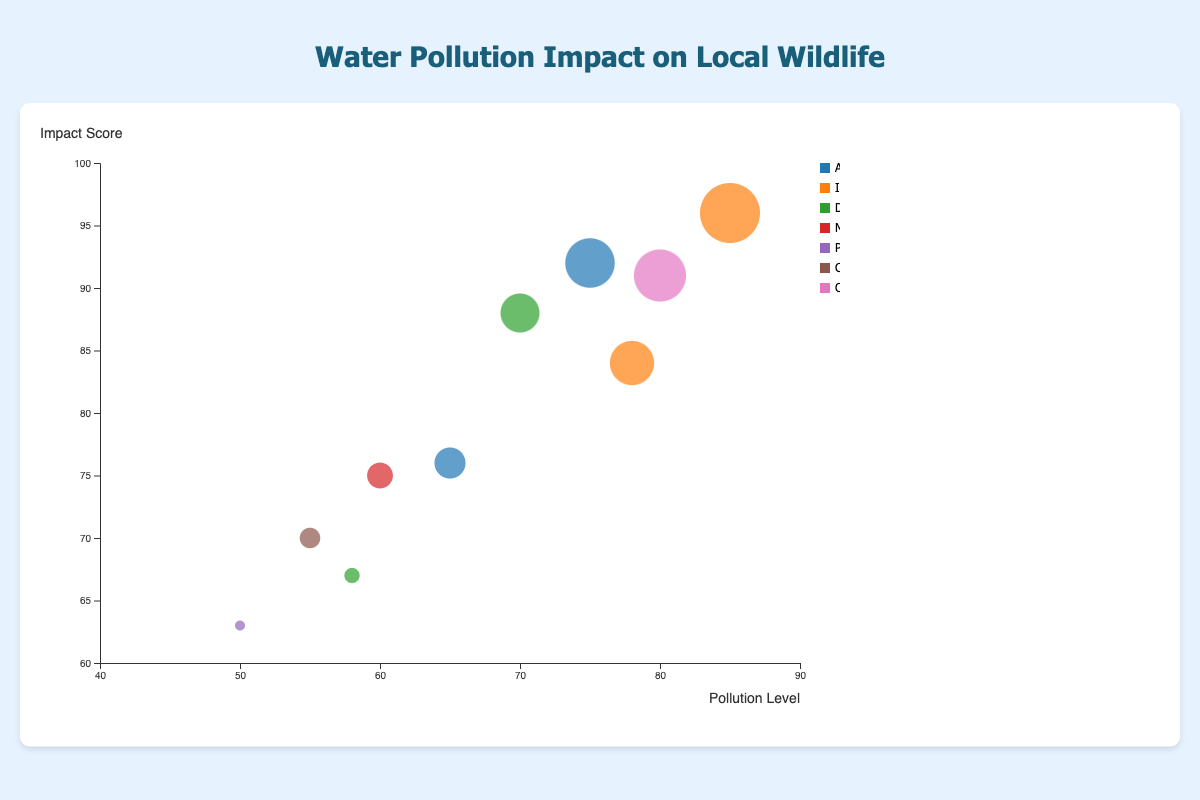What is the title of the chart? The title of the chart is usually displayed at the top and summarizes the visual's main topic. Here, the title "Water Pollution Impact on Local Wildlife" is clearly specified at the top.
Answer: Water Pollution Impact on Local Wildlife Which country has the highest Pollution Level? To identify this, look at the bubbles representing each country and check the x-axis, which denotes Pollution Level. The bubble with the farthest right position on the x-axis represents China, with a Pollution Level of 85.
Answer: China What is the Pollution Level for Japan? Locate the bubble labeled 'Japan' and check its x-axis position. The Pollution Level for Japan is represented as 58 on the x-axis.
Answer: 58 Which pollution source impacts the most wildlife in China? Refer to the bubble for China and observe the information provided. The tooltip or legend indicates that the Pollution Source for China is "Industrial Waste". The data shows that this source impacts 31 wildlife species.
Answer: Industrial Waste What is the range of Impact Scores visualized on the chart? Examine the y-axis of the bubble chart to determine the minimum and maximum Impact Scores. The range provided is from 60 to 100.
Answer: 60 to 100 How many countries have a Pollution Level greater than 70? Observe the x-axis positions of the bubbles and count the ones greater than 70. The countries are the United States (75), China (85), India (70), Russia (80), and South Africa (78). Thus, there are five countries with Pollution Levels greater than 70.
Answer: Five Which country has the largest bubble, and what does this signify? The size of the bubble signifies the number of Affected Wildlife. Identify the largest bubble visually, which is China, representing 31 affected wildlife species.
Answer: China What is the average Impact Score of countries represented by "Agricultural Runoff"? There are two countries with "Agricultural Runoff" as Pollution Source: the United States (Impact Score 92) and Canada (Impact Score 76). The average is calculated as (92 + 76) / 2 = 84.
Answer: 84 If you were to rank Australia and Germany by Pollution Level, which country ranks higher? Compare the x-axis positions for Australia and Germany. Australia's Pollution Level is 55, while Germany's is 50. Hence, Australia ranks higher in Pollution Level.
Answer: Australia Which country has the smallest Pollution Level, and what is its Impact Score? Identify the bubble with the smallest x-axis value. Germany has a Pollution Level of 50, and the corresponding Impact Score is 63.
Answer: Germany 